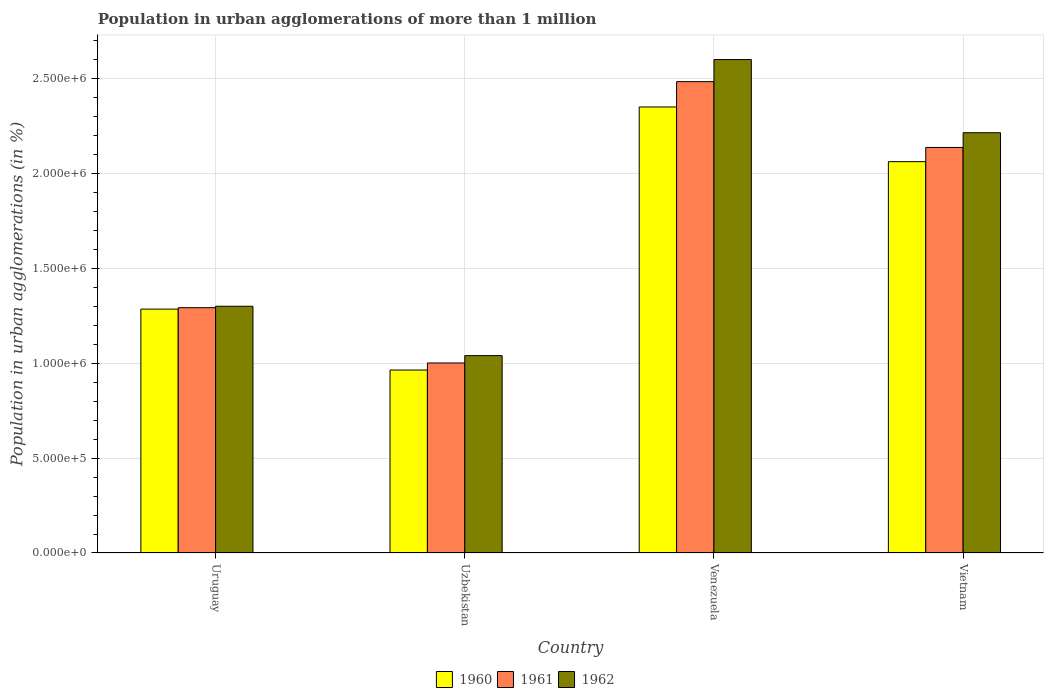How many groups of bars are there?
Your response must be concise. 4. Are the number of bars per tick equal to the number of legend labels?
Offer a terse response. Yes. Are the number of bars on each tick of the X-axis equal?
Your answer should be very brief. Yes. How many bars are there on the 4th tick from the right?
Keep it short and to the point. 3. What is the label of the 2nd group of bars from the left?
Your answer should be very brief. Uzbekistan. In how many cases, is the number of bars for a given country not equal to the number of legend labels?
Your response must be concise. 0. What is the population in urban agglomerations in 1962 in Uzbekistan?
Your answer should be very brief. 1.04e+06. Across all countries, what is the maximum population in urban agglomerations in 1961?
Keep it short and to the point. 2.48e+06. Across all countries, what is the minimum population in urban agglomerations in 1962?
Provide a succinct answer. 1.04e+06. In which country was the population in urban agglomerations in 1962 maximum?
Keep it short and to the point. Venezuela. In which country was the population in urban agglomerations in 1962 minimum?
Your answer should be compact. Uzbekistan. What is the total population in urban agglomerations in 1962 in the graph?
Keep it short and to the point. 7.15e+06. What is the difference between the population in urban agglomerations in 1962 in Uzbekistan and that in Vietnam?
Offer a very short reply. -1.17e+06. What is the difference between the population in urban agglomerations in 1960 in Vietnam and the population in urban agglomerations in 1962 in Uruguay?
Make the answer very short. 7.62e+05. What is the average population in urban agglomerations in 1961 per country?
Offer a very short reply. 1.73e+06. What is the difference between the population in urban agglomerations of/in 1961 and population in urban agglomerations of/in 1962 in Vietnam?
Your answer should be compact. -7.76e+04. In how many countries, is the population in urban agglomerations in 1961 greater than 2300000 %?
Your answer should be very brief. 1. What is the ratio of the population in urban agglomerations in 1962 in Uruguay to that in Venezuela?
Your response must be concise. 0.5. Is the population in urban agglomerations in 1962 in Uzbekistan less than that in Vietnam?
Your answer should be very brief. Yes. What is the difference between the highest and the second highest population in urban agglomerations in 1960?
Your answer should be compact. -2.88e+05. What is the difference between the highest and the lowest population in urban agglomerations in 1961?
Your response must be concise. 1.48e+06. Is the sum of the population in urban agglomerations in 1962 in Uruguay and Venezuela greater than the maximum population in urban agglomerations in 1960 across all countries?
Ensure brevity in your answer.  Yes. What does the 3rd bar from the right in Uzbekistan represents?
Provide a short and direct response. 1960. How many bars are there?
Give a very brief answer. 12. Are all the bars in the graph horizontal?
Provide a short and direct response. No. Are the values on the major ticks of Y-axis written in scientific E-notation?
Offer a very short reply. Yes. What is the title of the graph?
Offer a terse response. Population in urban agglomerations of more than 1 million. Does "1994" appear as one of the legend labels in the graph?
Keep it short and to the point. No. What is the label or title of the X-axis?
Give a very brief answer. Country. What is the label or title of the Y-axis?
Offer a terse response. Population in urban agglomerations (in %). What is the Population in urban agglomerations (in %) in 1960 in Uruguay?
Your answer should be very brief. 1.28e+06. What is the Population in urban agglomerations (in %) in 1961 in Uruguay?
Keep it short and to the point. 1.29e+06. What is the Population in urban agglomerations (in %) of 1962 in Uruguay?
Your answer should be compact. 1.30e+06. What is the Population in urban agglomerations (in %) of 1960 in Uzbekistan?
Your response must be concise. 9.64e+05. What is the Population in urban agglomerations (in %) in 1961 in Uzbekistan?
Ensure brevity in your answer.  1.00e+06. What is the Population in urban agglomerations (in %) of 1962 in Uzbekistan?
Your answer should be very brief. 1.04e+06. What is the Population in urban agglomerations (in %) of 1960 in Venezuela?
Provide a succinct answer. 2.35e+06. What is the Population in urban agglomerations (in %) in 1961 in Venezuela?
Make the answer very short. 2.48e+06. What is the Population in urban agglomerations (in %) of 1962 in Venezuela?
Make the answer very short. 2.60e+06. What is the Population in urban agglomerations (in %) in 1960 in Vietnam?
Offer a terse response. 2.06e+06. What is the Population in urban agglomerations (in %) in 1961 in Vietnam?
Make the answer very short. 2.14e+06. What is the Population in urban agglomerations (in %) in 1962 in Vietnam?
Ensure brevity in your answer.  2.21e+06. Across all countries, what is the maximum Population in urban agglomerations (in %) of 1960?
Your answer should be compact. 2.35e+06. Across all countries, what is the maximum Population in urban agglomerations (in %) in 1961?
Your answer should be compact. 2.48e+06. Across all countries, what is the maximum Population in urban agglomerations (in %) in 1962?
Offer a terse response. 2.60e+06. Across all countries, what is the minimum Population in urban agglomerations (in %) in 1960?
Your answer should be very brief. 9.64e+05. Across all countries, what is the minimum Population in urban agglomerations (in %) in 1961?
Your response must be concise. 1.00e+06. Across all countries, what is the minimum Population in urban agglomerations (in %) in 1962?
Your answer should be very brief. 1.04e+06. What is the total Population in urban agglomerations (in %) in 1960 in the graph?
Your answer should be compact. 6.66e+06. What is the total Population in urban agglomerations (in %) of 1961 in the graph?
Your answer should be compact. 6.91e+06. What is the total Population in urban agglomerations (in %) in 1962 in the graph?
Provide a short and direct response. 7.15e+06. What is the difference between the Population in urban agglomerations (in %) in 1960 in Uruguay and that in Uzbekistan?
Your response must be concise. 3.21e+05. What is the difference between the Population in urban agglomerations (in %) of 1961 in Uruguay and that in Uzbekistan?
Make the answer very short. 2.91e+05. What is the difference between the Population in urban agglomerations (in %) of 1962 in Uruguay and that in Uzbekistan?
Your answer should be compact. 2.60e+05. What is the difference between the Population in urban agglomerations (in %) in 1960 in Uruguay and that in Venezuela?
Offer a terse response. -1.07e+06. What is the difference between the Population in urban agglomerations (in %) of 1961 in Uruguay and that in Venezuela?
Make the answer very short. -1.19e+06. What is the difference between the Population in urban agglomerations (in %) of 1962 in Uruguay and that in Venezuela?
Offer a very short reply. -1.30e+06. What is the difference between the Population in urban agglomerations (in %) of 1960 in Uruguay and that in Vietnam?
Keep it short and to the point. -7.77e+05. What is the difference between the Population in urban agglomerations (in %) in 1961 in Uruguay and that in Vietnam?
Make the answer very short. -8.44e+05. What is the difference between the Population in urban agglomerations (in %) in 1962 in Uruguay and that in Vietnam?
Your answer should be very brief. -9.14e+05. What is the difference between the Population in urban agglomerations (in %) in 1960 in Uzbekistan and that in Venezuela?
Give a very brief answer. -1.39e+06. What is the difference between the Population in urban agglomerations (in %) of 1961 in Uzbekistan and that in Venezuela?
Your answer should be compact. -1.48e+06. What is the difference between the Population in urban agglomerations (in %) in 1962 in Uzbekistan and that in Venezuela?
Your answer should be compact. -1.56e+06. What is the difference between the Population in urban agglomerations (in %) of 1960 in Uzbekistan and that in Vietnam?
Give a very brief answer. -1.10e+06. What is the difference between the Population in urban agglomerations (in %) of 1961 in Uzbekistan and that in Vietnam?
Give a very brief answer. -1.14e+06. What is the difference between the Population in urban agglomerations (in %) in 1962 in Uzbekistan and that in Vietnam?
Give a very brief answer. -1.17e+06. What is the difference between the Population in urban agglomerations (in %) of 1960 in Venezuela and that in Vietnam?
Offer a very short reply. 2.88e+05. What is the difference between the Population in urban agglomerations (in %) in 1961 in Venezuela and that in Vietnam?
Ensure brevity in your answer.  3.47e+05. What is the difference between the Population in urban agglomerations (in %) of 1962 in Venezuela and that in Vietnam?
Provide a short and direct response. 3.86e+05. What is the difference between the Population in urban agglomerations (in %) of 1960 in Uruguay and the Population in urban agglomerations (in %) of 1961 in Uzbekistan?
Your answer should be compact. 2.84e+05. What is the difference between the Population in urban agglomerations (in %) of 1960 in Uruguay and the Population in urban agglomerations (in %) of 1962 in Uzbekistan?
Your answer should be compact. 2.45e+05. What is the difference between the Population in urban agglomerations (in %) in 1961 in Uruguay and the Population in urban agglomerations (in %) in 1962 in Uzbekistan?
Offer a terse response. 2.53e+05. What is the difference between the Population in urban agglomerations (in %) of 1960 in Uruguay and the Population in urban agglomerations (in %) of 1961 in Venezuela?
Give a very brief answer. -1.20e+06. What is the difference between the Population in urban agglomerations (in %) in 1960 in Uruguay and the Population in urban agglomerations (in %) in 1962 in Venezuela?
Provide a short and direct response. -1.31e+06. What is the difference between the Population in urban agglomerations (in %) in 1961 in Uruguay and the Population in urban agglomerations (in %) in 1962 in Venezuela?
Give a very brief answer. -1.31e+06. What is the difference between the Population in urban agglomerations (in %) of 1960 in Uruguay and the Population in urban agglomerations (in %) of 1961 in Vietnam?
Make the answer very short. -8.52e+05. What is the difference between the Population in urban agglomerations (in %) of 1960 in Uruguay and the Population in urban agglomerations (in %) of 1962 in Vietnam?
Give a very brief answer. -9.29e+05. What is the difference between the Population in urban agglomerations (in %) of 1961 in Uruguay and the Population in urban agglomerations (in %) of 1962 in Vietnam?
Your response must be concise. -9.22e+05. What is the difference between the Population in urban agglomerations (in %) of 1960 in Uzbekistan and the Population in urban agglomerations (in %) of 1961 in Venezuela?
Your answer should be compact. -1.52e+06. What is the difference between the Population in urban agglomerations (in %) in 1960 in Uzbekistan and the Population in urban agglomerations (in %) in 1962 in Venezuela?
Give a very brief answer. -1.64e+06. What is the difference between the Population in urban agglomerations (in %) in 1961 in Uzbekistan and the Population in urban agglomerations (in %) in 1962 in Venezuela?
Give a very brief answer. -1.60e+06. What is the difference between the Population in urban agglomerations (in %) in 1960 in Uzbekistan and the Population in urban agglomerations (in %) in 1961 in Vietnam?
Your response must be concise. -1.17e+06. What is the difference between the Population in urban agglomerations (in %) of 1960 in Uzbekistan and the Population in urban agglomerations (in %) of 1962 in Vietnam?
Your answer should be compact. -1.25e+06. What is the difference between the Population in urban agglomerations (in %) in 1961 in Uzbekistan and the Population in urban agglomerations (in %) in 1962 in Vietnam?
Your answer should be very brief. -1.21e+06. What is the difference between the Population in urban agglomerations (in %) in 1960 in Venezuela and the Population in urban agglomerations (in %) in 1961 in Vietnam?
Offer a very short reply. 2.13e+05. What is the difference between the Population in urban agglomerations (in %) in 1960 in Venezuela and the Population in urban agglomerations (in %) in 1962 in Vietnam?
Your response must be concise. 1.36e+05. What is the difference between the Population in urban agglomerations (in %) in 1961 in Venezuela and the Population in urban agglomerations (in %) in 1962 in Vietnam?
Keep it short and to the point. 2.69e+05. What is the average Population in urban agglomerations (in %) in 1960 per country?
Give a very brief answer. 1.67e+06. What is the average Population in urban agglomerations (in %) in 1961 per country?
Offer a terse response. 1.73e+06. What is the average Population in urban agglomerations (in %) in 1962 per country?
Make the answer very short. 1.79e+06. What is the difference between the Population in urban agglomerations (in %) in 1960 and Population in urban agglomerations (in %) in 1961 in Uruguay?
Offer a very short reply. -7522. What is the difference between the Population in urban agglomerations (in %) in 1960 and Population in urban agglomerations (in %) in 1962 in Uruguay?
Offer a terse response. -1.51e+04. What is the difference between the Population in urban agglomerations (in %) in 1961 and Population in urban agglomerations (in %) in 1962 in Uruguay?
Keep it short and to the point. -7578. What is the difference between the Population in urban agglomerations (in %) in 1960 and Population in urban agglomerations (in %) in 1961 in Uzbekistan?
Make the answer very short. -3.73e+04. What is the difference between the Population in urban agglomerations (in %) in 1960 and Population in urban agglomerations (in %) in 1962 in Uzbekistan?
Your answer should be compact. -7.60e+04. What is the difference between the Population in urban agglomerations (in %) of 1961 and Population in urban agglomerations (in %) of 1962 in Uzbekistan?
Provide a short and direct response. -3.88e+04. What is the difference between the Population in urban agglomerations (in %) of 1960 and Population in urban agglomerations (in %) of 1961 in Venezuela?
Your answer should be compact. -1.33e+05. What is the difference between the Population in urban agglomerations (in %) in 1960 and Population in urban agglomerations (in %) in 1962 in Venezuela?
Ensure brevity in your answer.  -2.50e+05. What is the difference between the Population in urban agglomerations (in %) in 1961 and Population in urban agglomerations (in %) in 1962 in Venezuela?
Provide a short and direct response. -1.16e+05. What is the difference between the Population in urban agglomerations (in %) in 1960 and Population in urban agglomerations (in %) in 1961 in Vietnam?
Make the answer very short. -7.48e+04. What is the difference between the Population in urban agglomerations (in %) in 1960 and Population in urban agglomerations (in %) in 1962 in Vietnam?
Offer a very short reply. -1.52e+05. What is the difference between the Population in urban agglomerations (in %) of 1961 and Population in urban agglomerations (in %) of 1962 in Vietnam?
Your answer should be very brief. -7.76e+04. What is the ratio of the Population in urban agglomerations (in %) in 1960 in Uruguay to that in Uzbekistan?
Ensure brevity in your answer.  1.33. What is the ratio of the Population in urban agglomerations (in %) of 1961 in Uruguay to that in Uzbekistan?
Your response must be concise. 1.29. What is the ratio of the Population in urban agglomerations (in %) of 1962 in Uruguay to that in Uzbekistan?
Offer a very short reply. 1.25. What is the ratio of the Population in urban agglomerations (in %) of 1960 in Uruguay to that in Venezuela?
Your answer should be very brief. 0.55. What is the ratio of the Population in urban agglomerations (in %) of 1961 in Uruguay to that in Venezuela?
Your response must be concise. 0.52. What is the ratio of the Population in urban agglomerations (in %) of 1962 in Uruguay to that in Venezuela?
Offer a terse response. 0.5. What is the ratio of the Population in urban agglomerations (in %) in 1960 in Uruguay to that in Vietnam?
Offer a very short reply. 0.62. What is the ratio of the Population in urban agglomerations (in %) of 1961 in Uruguay to that in Vietnam?
Offer a very short reply. 0.6. What is the ratio of the Population in urban agglomerations (in %) of 1962 in Uruguay to that in Vietnam?
Offer a very short reply. 0.59. What is the ratio of the Population in urban agglomerations (in %) in 1960 in Uzbekistan to that in Venezuela?
Make the answer very short. 0.41. What is the ratio of the Population in urban agglomerations (in %) of 1961 in Uzbekistan to that in Venezuela?
Provide a short and direct response. 0.4. What is the ratio of the Population in urban agglomerations (in %) in 1962 in Uzbekistan to that in Venezuela?
Your answer should be very brief. 0.4. What is the ratio of the Population in urban agglomerations (in %) in 1960 in Uzbekistan to that in Vietnam?
Offer a terse response. 0.47. What is the ratio of the Population in urban agglomerations (in %) of 1961 in Uzbekistan to that in Vietnam?
Keep it short and to the point. 0.47. What is the ratio of the Population in urban agglomerations (in %) in 1962 in Uzbekistan to that in Vietnam?
Your answer should be compact. 0.47. What is the ratio of the Population in urban agglomerations (in %) of 1960 in Venezuela to that in Vietnam?
Offer a terse response. 1.14. What is the ratio of the Population in urban agglomerations (in %) of 1961 in Venezuela to that in Vietnam?
Provide a short and direct response. 1.16. What is the ratio of the Population in urban agglomerations (in %) in 1962 in Venezuela to that in Vietnam?
Keep it short and to the point. 1.17. What is the difference between the highest and the second highest Population in urban agglomerations (in %) in 1960?
Give a very brief answer. 2.88e+05. What is the difference between the highest and the second highest Population in urban agglomerations (in %) of 1961?
Provide a short and direct response. 3.47e+05. What is the difference between the highest and the second highest Population in urban agglomerations (in %) in 1962?
Ensure brevity in your answer.  3.86e+05. What is the difference between the highest and the lowest Population in urban agglomerations (in %) in 1960?
Your answer should be compact. 1.39e+06. What is the difference between the highest and the lowest Population in urban agglomerations (in %) of 1961?
Provide a succinct answer. 1.48e+06. What is the difference between the highest and the lowest Population in urban agglomerations (in %) in 1962?
Keep it short and to the point. 1.56e+06. 